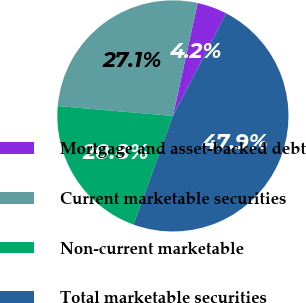Convert chart. <chart><loc_0><loc_0><loc_500><loc_500><pie_chart><fcel>Mortgage and asset-backed debt<fcel>Current marketable securities<fcel>Non-current marketable<fcel>Total marketable securities<nl><fcel>4.17%<fcel>27.08%<fcel>20.83%<fcel>47.92%<nl></chart> 